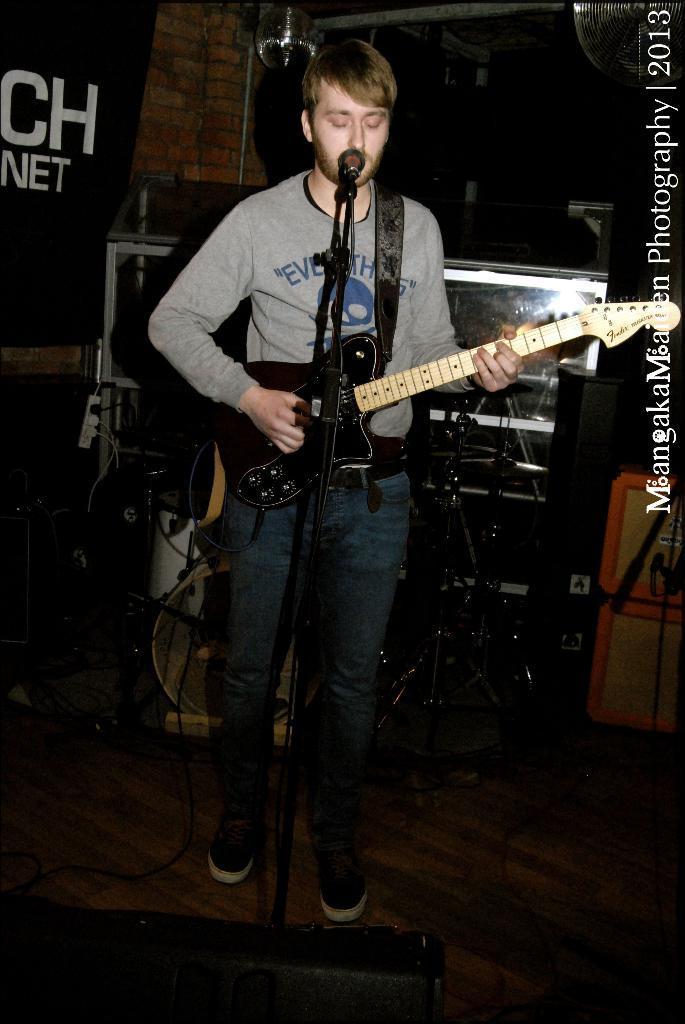Please provide a concise description of this image. In this image we can see person standing and holding a guitar at the mic. In the background we can see monitors, musical instruments, banner and wall. 